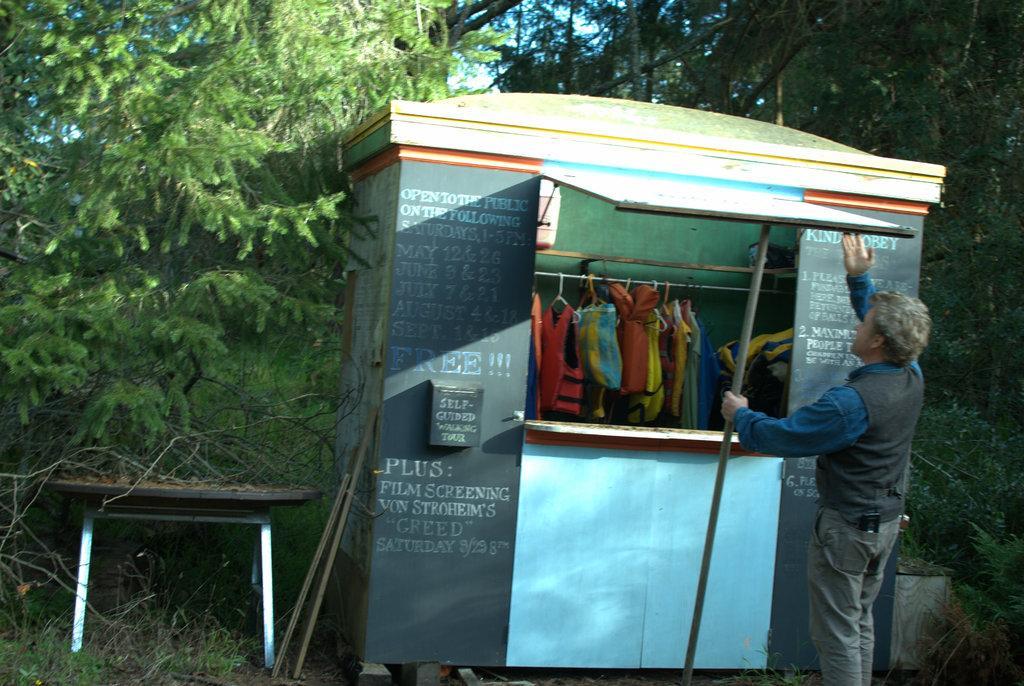In one or two sentences, can you explain what this image depicts? In this image I can see a tent , under the tent I can see hanger ,on the hanger I can see clothes and I can see a person standing in front of the tent , holding a rod ,at the top I can see trees, beside the tent on the left side I can see a bench and I can see sticks attached to the tent. 